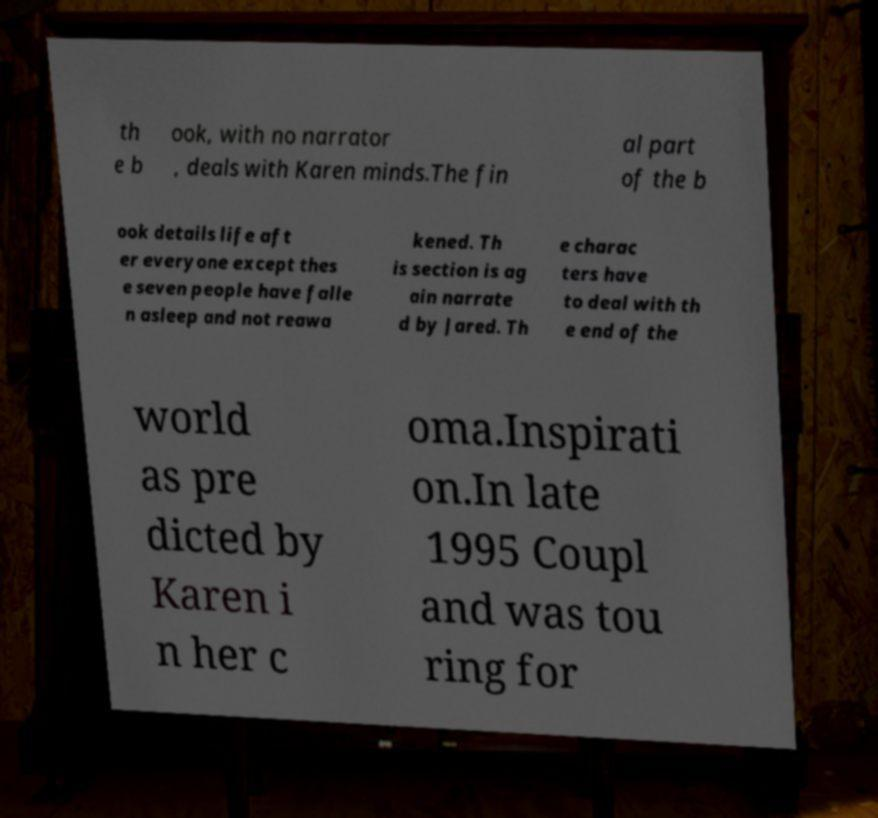Please read and relay the text visible in this image. What does it say? th e b ook, with no narrator , deals with Karen minds.The fin al part of the b ook details life aft er everyone except thes e seven people have falle n asleep and not reawa kened. Th is section is ag ain narrate d by Jared. Th e charac ters have to deal with th e end of the world as pre dicted by Karen i n her c oma.Inspirati on.In late 1995 Coupl and was tou ring for 